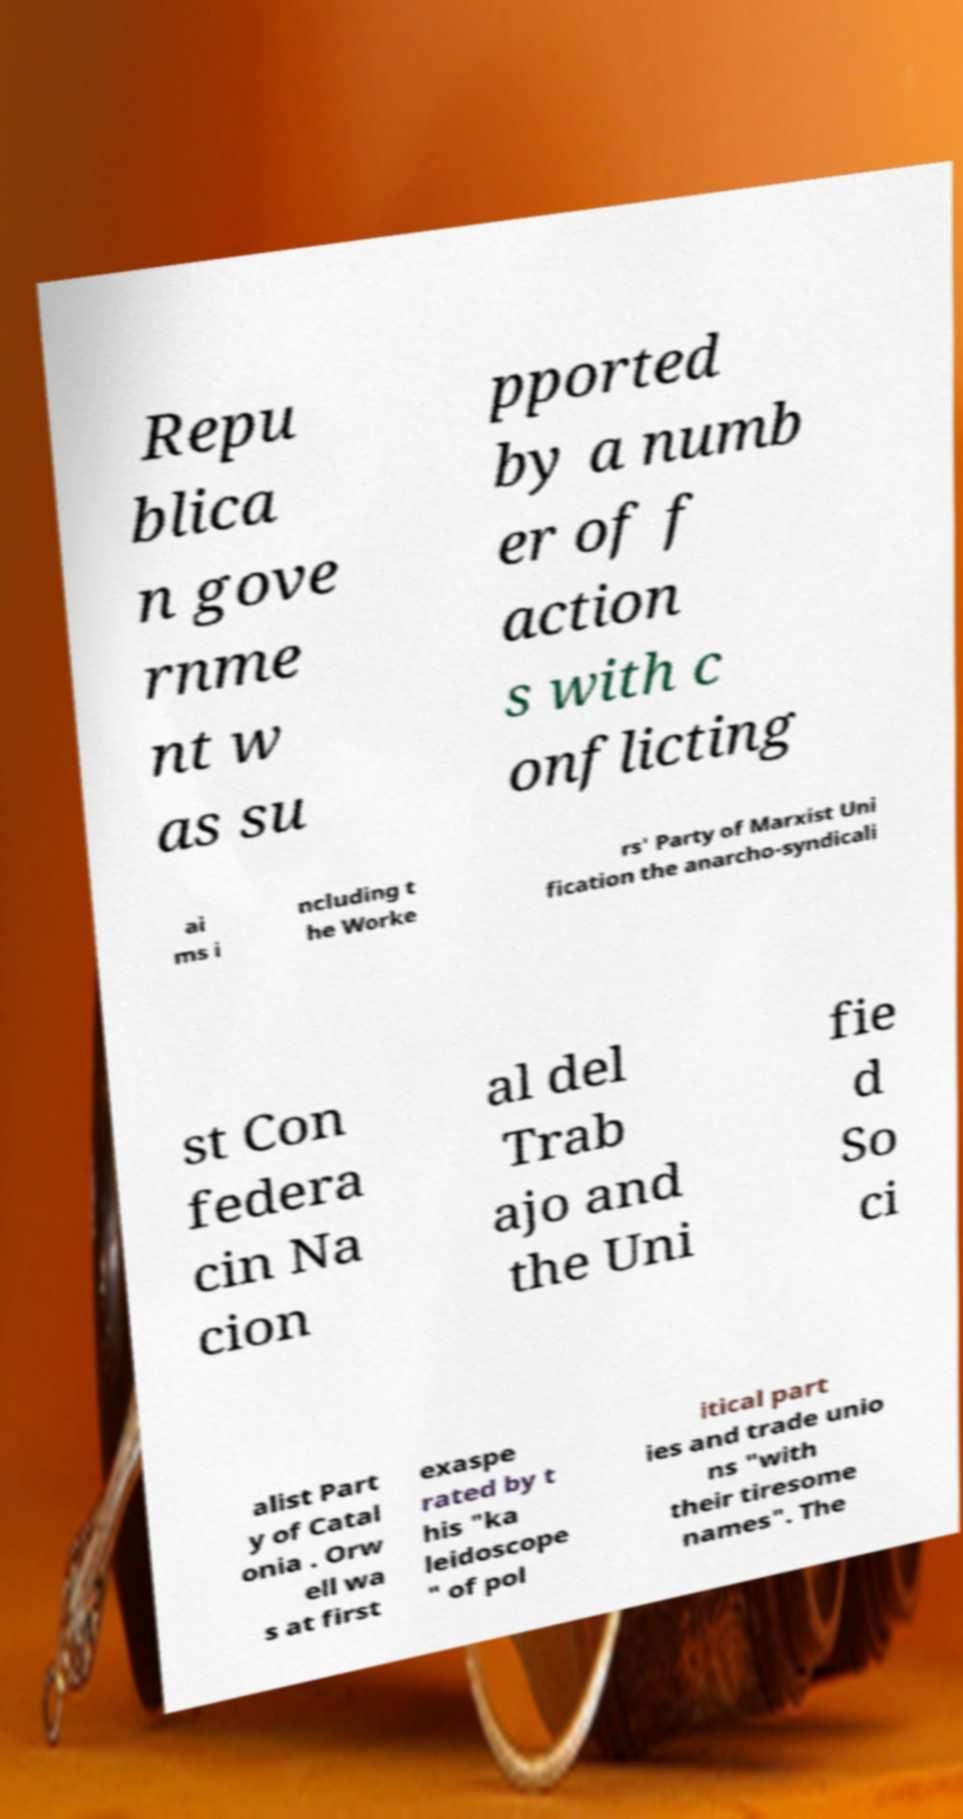Can you read and provide the text displayed in the image?This photo seems to have some interesting text. Can you extract and type it out for me? Repu blica n gove rnme nt w as su pported by a numb er of f action s with c onflicting ai ms i ncluding t he Worke rs' Party of Marxist Uni fication the anarcho-syndicali st Con federa cin Na cion al del Trab ajo and the Uni fie d So ci alist Part y of Catal onia . Orw ell wa s at first exaspe rated by t his "ka leidoscope " of pol itical part ies and trade unio ns "with their tiresome names". The 